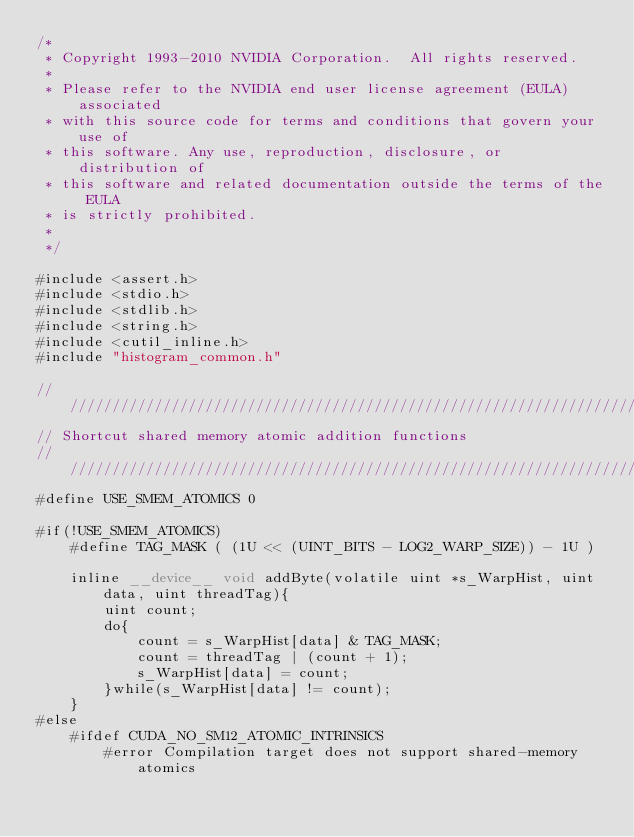Convert code to text. <code><loc_0><loc_0><loc_500><loc_500><_Cuda_>/*
 * Copyright 1993-2010 NVIDIA Corporation.  All rights reserved.
 *
 * Please refer to the NVIDIA end user license agreement (EULA) associated
 * with this source code for terms and conditions that govern your use of
 * this software. Any use, reproduction, disclosure, or distribution of
 * this software and related documentation outside the terms of the EULA
 * is strictly prohibited.
 *
 */

#include <assert.h>
#include <stdio.h>
#include <stdlib.h>
#include <string.h>
#include <cutil_inline.h>
#include "histogram_common.h"

////////////////////////////////////////////////////////////////////////////////
// Shortcut shared memory atomic addition functions
////////////////////////////////////////////////////////////////////////////////
#define USE_SMEM_ATOMICS 0

#if(!USE_SMEM_ATOMICS)
    #define TAG_MASK ( (1U << (UINT_BITS - LOG2_WARP_SIZE)) - 1U )

    inline __device__ void addByte(volatile uint *s_WarpHist, uint data, uint threadTag){
        uint count;
        do{
            count = s_WarpHist[data] & TAG_MASK;
            count = threadTag | (count + 1);
            s_WarpHist[data] = count;
        }while(s_WarpHist[data] != count);
    }
#else
    #ifdef CUDA_NO_SM12_ATOMIC_INTRINSICS
        #error Compilation target does not support shared-memory atomics</code> 